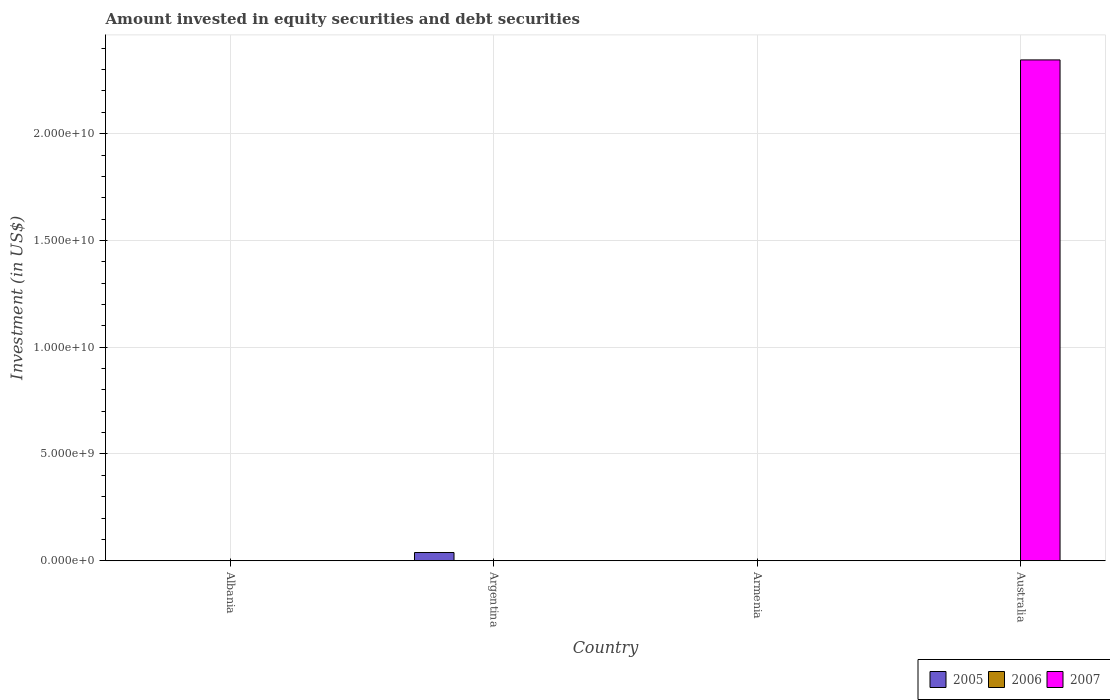How many different coloured bars are there?
Give a very brief answer. 2. Are the number of bars per tick equal to the number of legend labels?
Your answer should be compact. No. Are the number of bars on each tick of the X-axis equal?
Provide a succinct answer. No. How many bars are there on the 4th tick from the right?
Provide a succinct answer. 1. What is the label of the 3rd group of bars from the left?
Your answer should be very brief. Armenia. What is the amount invested in equity securities and debt securities in 2006 in Albania?
Provide a succinct answer. 0. Across all countries, what is the maximum amount invested in equity securities and debt securities in 2007?
Provide a short and direct response. 2.35e+1. What is the total amount invested in equity securities and debt securities in 2005 in the graph?
Give a very brief answer. 3.95e+08. What is the difference between the amount invested in equity securities and debt securities in 2007 in Armenia and that in Australia?
Your response must be concise. -2.34e+1. What is the difference between the amount invested in equity securities and debt securities in 2005 in Armenia and the amount invested in equity securities and debt securities in 2007 in Australia?
Keep it short and to the point. -2.34e+1. What is the average amount invested in equity securities and debt securities in 2005 per country?
Your response must be concise. 9.87e+07. In how many countries, is the amount invested in equity securities and debt securities in 2006 greater than 16000000000 US$?
Make the answer very short. 0. What is the ratio of the amount invested in equity securities and debt securities in 2007 in Armenia to that in Australia?
Provide a short and direct response. 0. Is the amount invested in equity securities and debt securities in 2007 in Armenia less than that in Australia?
Provide a succinct answer. Yes. What is the difference between the highest and the second highest amount invested in equity securities and debt securities in 2005?
Provide a short and direct response. 3.81e+08. What is the difference between the highest and the lowest amount invested in equity securities and debt securities in 2005?
Your answer should be compact. 3.86e+08. How many bars are there?
Your response must be concise. 5. Are all the bars in the graph horizontal?
Your response must be concise. No. What is the title of the graph?
Provide a short and direct response. Amount invested in equity securities and debt securities. Does "1991" appear as one of the legend labels in the graph?
Ensure brevity in your answer.  No. What is the label or title of the Y-axis?
Give a very brief answer. Investment (in US$). What is the Investment (in US$) of 2005 in Albania?
Make the answer very short. 5.66e+06. What is the Investment (in US$) in 2006 in Albania?
Ensure brevity in your answer.  0. What is the Investment (in US$) in 2007 in Albania?
Offer a terse response. 0. What is the Investment (in US$) of 2005 in Argentina?
Offer a terse response. 3.86e+08. What is the Investment (in US$) of 2007 in Argentina?
Your answer should be very brief. 0. What is the Investment (in US$) in 2005 in Armenia?
Your response must be concise. 2.79e+06. What is the Investment (in US$) of 2006 in Armenia?
Provide a short and direct response. 0. What is the Investment (in US$) of 2007 in Armenia?
Offer a terse response. 8.01e+06. What is the Investment (in US$) of 2005 in Australia?
Keep it short and to the point. 0. What is the Investment (in US$) in 2007 in Australia?
Provide a succinct answer. 2.35e+1. Across all countries, what is the maximum Investment (in US$) in 2005?
Make the answer very short. 3.86e+08. Across all countries, what is the maximum Investment (in US$) in 2007?
Offer a terse response. 2.35e+1. What is the total Investment (in US$) of 2005 in the graph?
Offer a terse response. 3.95e+08. What is the total Investment (in US$) in 2006 in the graph?
Your response must be concise. 0. What is the total Investment (in US$) of 2007 in the graph?
Make the answer very short. 2.35e+1. What is the difference between the Investment (in US$) of 2005 in Albania and that in Argentina?
Give a very brief answer. -3.81e+08. What is the difference between the Investment (in US$) in 2005 in Albania and that in Armenia?
Provide a short and direct response. 2.88e+06. What is the difference between the Investment (in US$) in 2005 in Argentina and that in Armenia?
Offer a very short reply. 3.84e+08. What is the difference between the Investment (in US$) in 2007 in Armenia and that in Australia?
Give a very brief answer. -2.34e+1. What is the difference between the Investment (in US$) of 2005 in Albania and the Investment (in US$) of 2007 in Armenia?
Provide a short and direct response. -2.34e+06. What is the difference between the Investment (in US$) of 2005 in Albania and the Investment (in US$) of 2007 in Australia?
Provide a short and direct response. -2.34e+1. What is the difference between the Investment (in US$) in 2005 in Argentina and the Investment (in US$) in 2007 in Armenia?
Give a very brief answer. 3.78e+08. What is the difference between the Investment (in US$) in 2005 in Argentina and the Investment (in US$) in 2007 in Australia?
Provide a succinct answer. -2.31e+1. What is the difference between the Investment (in US$) in 2005 in Armenia and the Investment (in US$) in 2007 in Australia?
Provide a short and direct response. -2.34e+1. What is the average Investment (in US$) in 2005 per country?
Give a very brief answer. 9.87e+07. What is the average Investment (in US$) in 2007 per country?
Offer a very short reply. 5.87e+09. What is the difference between the Investment (in US$) in 2005 and Investment (in US$) in 2007 in Armenia?
Provide a short and direct response. -5.22e+06. What is the ratio of the Investment (in US$) of 2005 in Albania to that in Argentina?
Provide a short and direct response. 0.01. What is the ratio of the Investment (in US$) of 2005 in Albania to that in Armenia?
Your answer should be compact. 2.03. What is the ratio of the Investment (in US$) in 2005 in Argentina to that in Armenia?
Provide a succinct answer. 138.56. What is the ratio of the Investment (in US$) of 2007 in Armenia to that in Australia?
Provide a short and direct response. 0. What is the difference between the highest and the second highest Investment (in US$) in 2005?
Your response must be concise. 3.81e+08. What is the difference between the highest and the lowest Investment (in US$) in 2005?
Your response must be concise. 3.86e+08. What is the difference between the highest and the lowest Investment (in US$) in 2007?
Keep it short and to the point. 2.35e+1. 